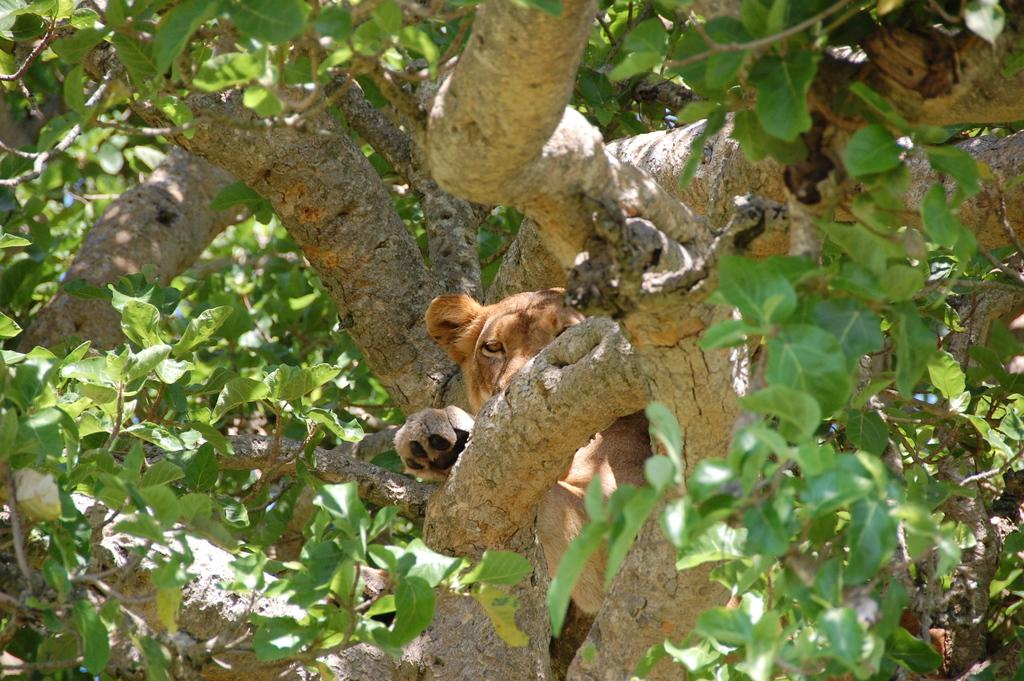What is the main subject in the center of the image? There is a cub in the center of the image. Where is the cub located? The cub is on a tree. What type of vegetation can be seen in the image? There are leaves and branches in the image. What type of shirt is the cub wearing in the image? There is no shirt present in the image, as the cub is a wild animal and does not wear clothing. 